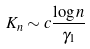Convert formula to latex. <formula><loc_0><loc_0><loc_500><loc_500>K _ { n } \sim c \frac { \log n } { \gamma _ { 1 } }</formula> 